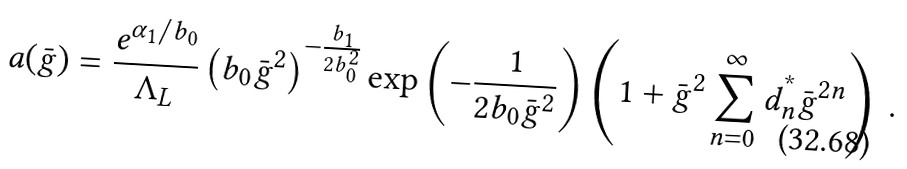Convert formula to latex. <formula><loc_0><loc_0><loc_500><loc_500>a ( \bar { g } ) = \frac { e ^ { \alpha _ { 1 } / b _ { 0 } } } { \Lambda _ { L } } \left ( b _ { 0 } \bar { g } ^ { 2 } \right ) ^ { - \frac { b _ { 1 } } { 2 b _ { 0 } ^ { 2 } } } \exp \left ( - \frac { 1 } { 2 b _ { 0 } \bar { g } ^ { 2 } } \right ) \left ( 1 + \bar { g } ^ { 2 } \sum _ { n = 0 } ^ { \infty } d _ { n } ^ { ^ { * } } \bar { g } ^ { 2 n } \right ) \ .</formula> 